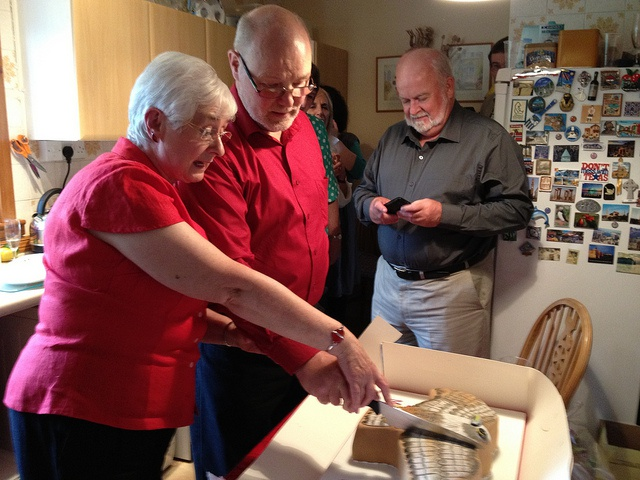Describe the objects in this image and their specific colors. I can see people in beige, maroon, black, and brown tones, refrigerator in beige, darkgray, gray, and black tones, people in beige, black, gray, maroon, and brown tones, people in beige, maroon, brown, and red tones, and cake in beige, tan, gray, and maroon tones in this image. 